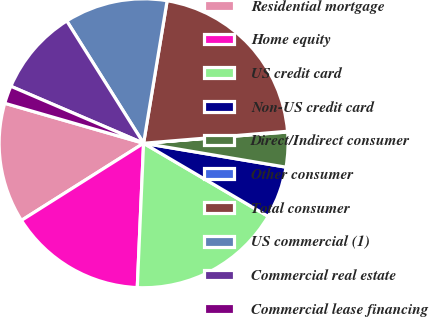<chart> <loc_0><loc_0><loc_500><loc_500><pie_chart><fcel>Residential mortgage<fcel>Home equity<fcel>US credit card<fcel>Non-US credit card<fcel>Direct/Indirect consumer<fcel>Other consumer<fcel>Total consumer<fcel>US commercial (1)<fcel>Commercial real estate<fcel>Commercial lease financing<nl><fcel>13.43%<fcel>15.34%<fcel>17.25%<fcel>5.8%<fcel>3.89%<fcel>0.08%<fcel>21.07%<fcel>11.53%<fcel>9.62%<fcel>1.99%<nl></chart> 